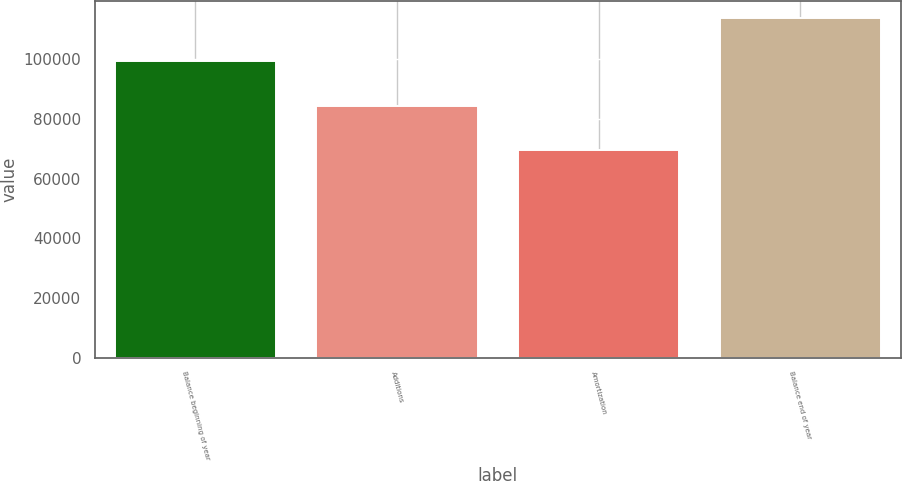<chart> <loc_0><loc_0><loc_500><loc_500><bar_chart><fcel>Balance beginning of year<fcel>Additions<fcel>Amortization<fcel>Balance end of year<nl><fcel>99265<fcel>84274<fcel>69718<fcel>113821<nl></chart> 